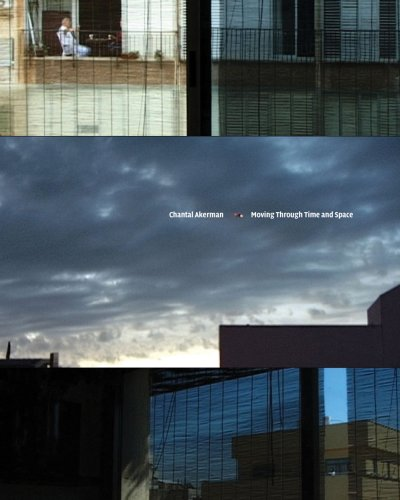What type of book is this? This is an Arts & Photography book, focusing on the cinematic and artistic achievements of Chantal Akerman, providing a visual and critical exploration of her work. 